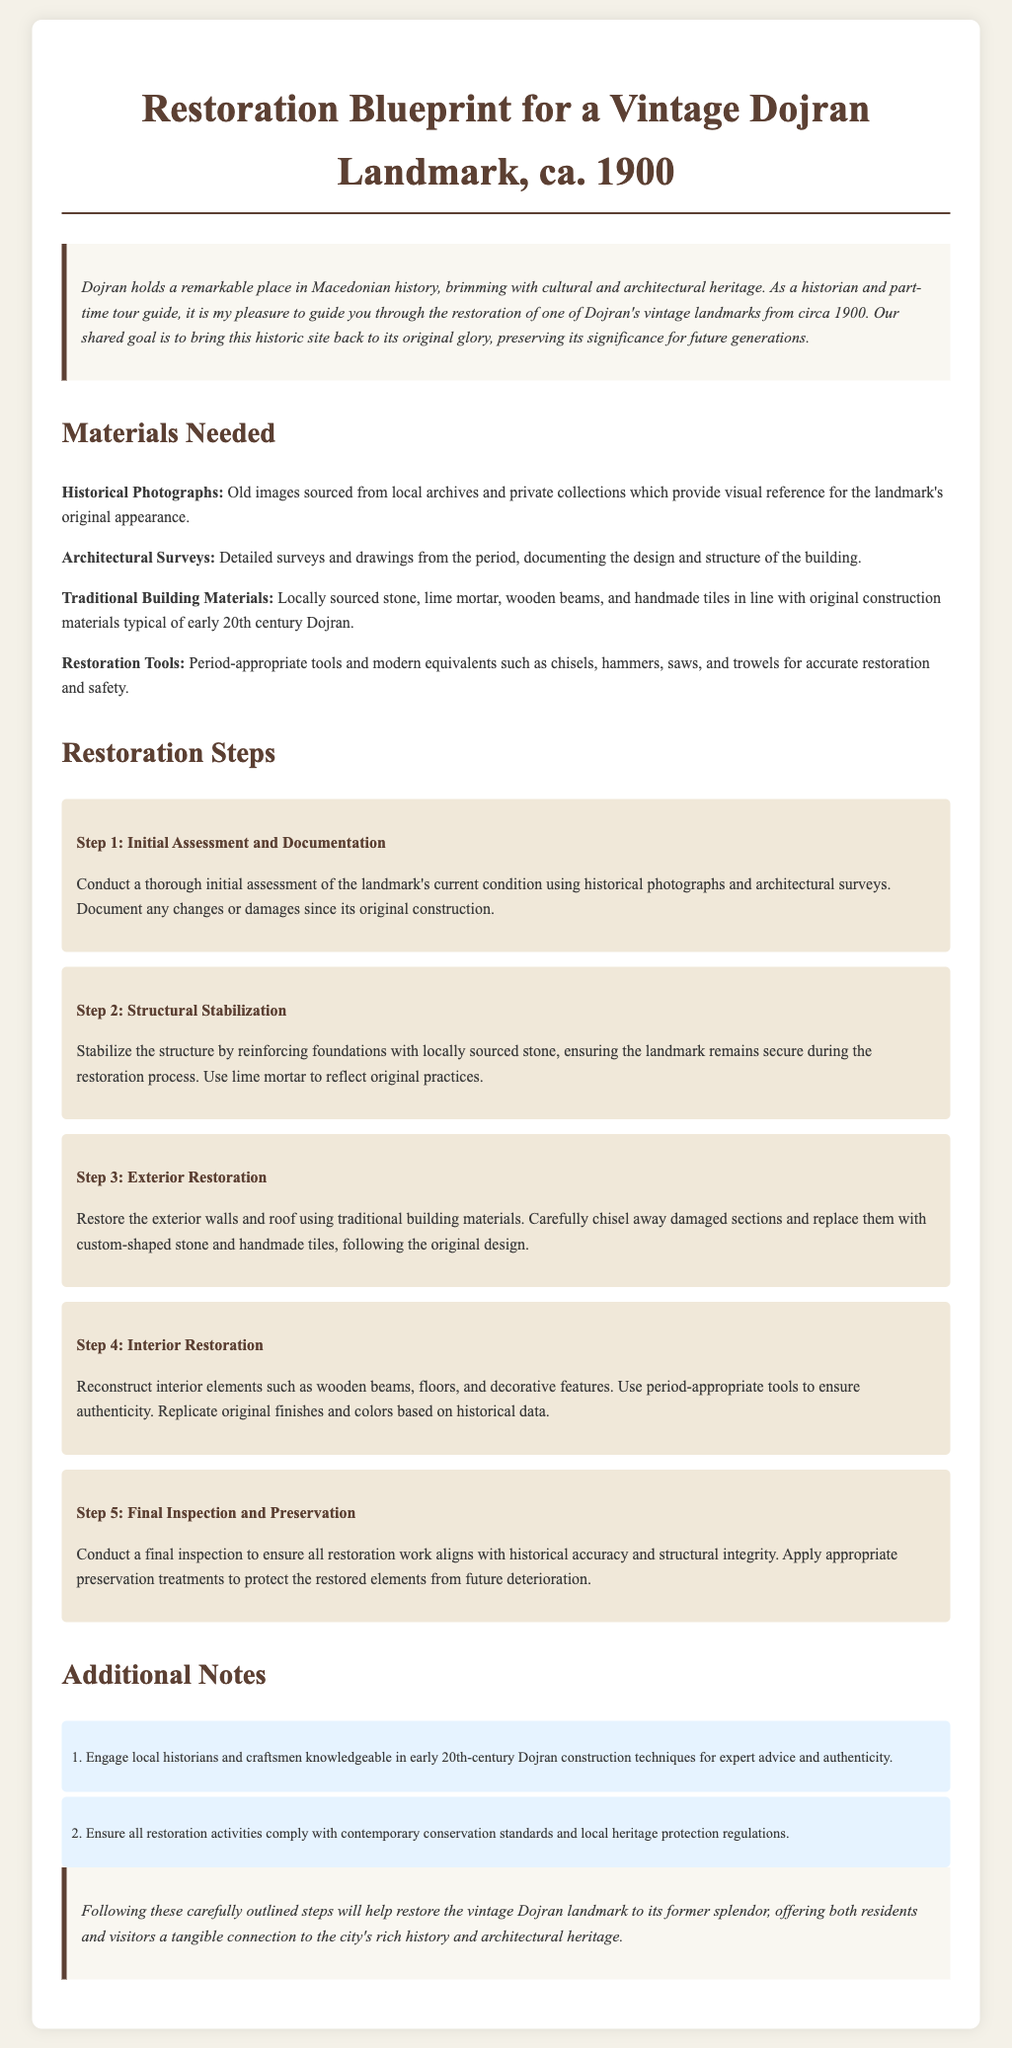what is the title of the document? The title of the document is specified in the <title> tag, which reads "Restoration Blueprint for a Vintage Dojran Landmark, ca. 1900."
Answer: Restoration Blueprint for a Vintage Dojran Landmark, ca. 1900 how many restoration steps are listed? The document outlines a total of five restoration steps in the "Restoration Steps" section.
Answer: 5 what is the material needed for restoring the interior? The document mentions reconstructing interior elements using wooden beams, floors, and decorative features for restoration.
Answer: Wooden beams, floors, and decorative features what is the primary type of mortar suggested for structural stabilization? The text specifies that lime mortar should be used during the structural stabilization step, reflecting original practices.
Answer: Lime mortar who are the professionals recommended for engagement during the restoration process? The document suggests engaging local historians and craftsmen with knowledge of early 20th-century Dojran construction techniques.
Answer: Local historians and craftsmen what should be ensured during restoration activities? The document states that all restoration activities must comply with contemporary conservation standards and local heritage protection regulations.
Answer: Compliance with conservation standards and regulations what is the color scheme noted in the introduction? The introduction does not specify a color scheme, but it mentions the historic significance of the vintage Dojran landmark to convey a sense of preservation.
Answer: Historic significance what type of photographs are needed for the restoration? The document emphasizes the need for historical photographs sourced from local archives and private collections for visual reference.
Answer: Historical photographs what is the intended outcome of following the restoration steps? The conclusion notes that the carefully outlined steps aim to restore the vintage Dojran landmark to its former splendor, preserving its significance.
Answer: Restore the vintage Dojran landmark to its former splendor 